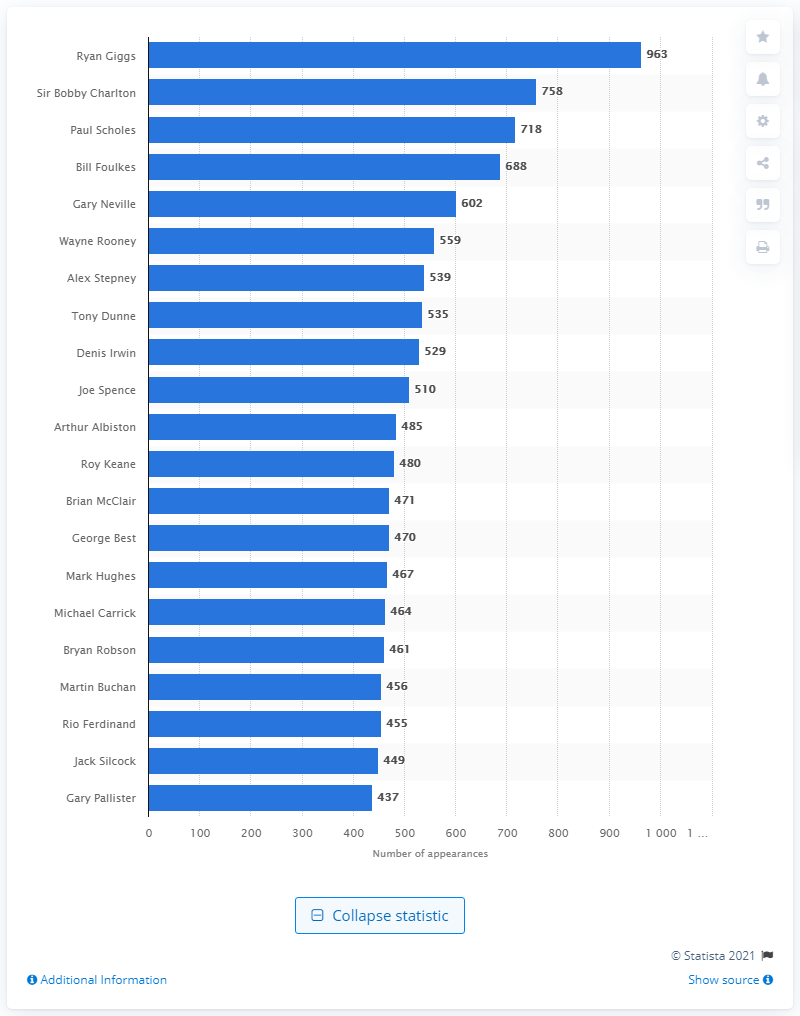Give some essential details in this illustration. It is Ryan Giggs who holds the all-time record for the most appearances for Manchester United. Ryan Giggs played a total of 963 games for Manchester United between 1991 and 2014. 